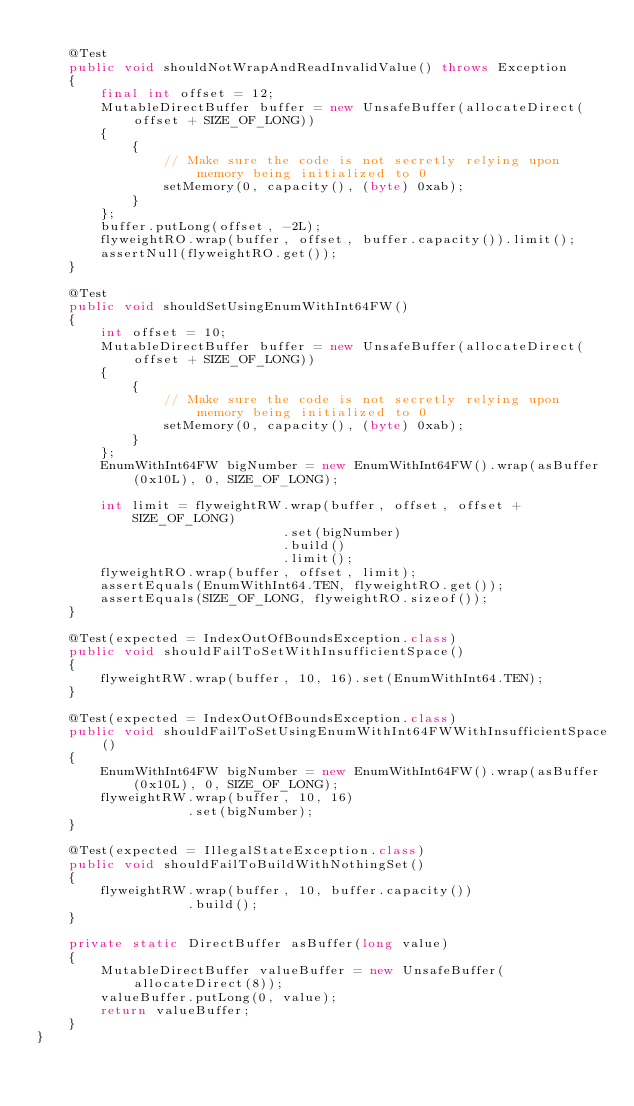Convert code to text. <code><loc_0><loc_0><loc_500><loc_500><_Java_>
    @Test
    public void shouldNotWrapAndReadInvalidValue() throws Exception
    {
        final int offset = 12;
        MutableDirectBuffer buffer = new UnsafeBuffer(allocateDirect(offset + SIZE_OF_LONG))
        {
            {
                // Make sure the code is not secretly relying upon memory being initialized to 0
                setMemory(0, capacity(), (byte) 0xab);
            }
        };
        buffer.putLong(offset, -2L);
        flyweightRO.wrap(buffer, offset, buffer.capacity()).limit();
        assertNull(flyweightRO.get());
    }

    @Test
    public void shouldSetUsingEnumWithInt64FW()
    {
        int offset = 10;
        MutableDirectBuffer buffer = new UnsafeBuffer(allocateDirect(offset + SIZE_OF_LONG))
        {
            {
                // Make sure the code is not secretly relying upon memory being initialized to 0
                setMemory(0, capacity(), (byte) 0xab);
            }
        };
        EnumWithInt64FW bigNumber = new EnumWithInt64FW().wrap(asBuffer(0x10L), 0, SIZE_OF_LONG);

        int limit = flyweightRW.wrap(buffer, offset, offset + SIZE_OF_LONG)
                               .set(bigNumber)
                               .build()
                               .limit();
        flyweightRO.wrap(buffer, offset, limit);
        assertEquals(EnumWithInt64.TEN, flyweightRO.get());
        assertEquals(SIZE_OF_LONG, flyweightRO.sizeof());
    }

    @Test(expected = IndexOutOfBoundsException.class)
    public void shouldFailToSetWithInsufficientSpace()
    {
        flyweightRW.wrap(buffer, 10, 16).set(EnumWithInt64.TEN);
    }

    @Test(expected = IndexOutOfBoundsException.class)
    public void shouldFailToSetUsingEnumWithInt64FWWithInsufficientSpace()
    {
        EnumWithInt64FW bigNumber = new EnumWithInt64FW().wrap(asBuffer(0x10L), 0, SIZE_OF_LONG);
        flyweightRW.wrap(buffer, 10, 16)
                   .set(bigNumber);
    }

    @Test(expected = IllegalStateException.class)
    public void shouldFailToBuildWithNothingSet()
    {
        flyweightRW.wrap(buffer, 10, buffer.capacity())
                   .build();
    }

    private static DirectBuffer asBuffer(long value)
    {
        MutableDirectBuffer valueBuffer = new UnsafeBuffer(allocateDirect(8));
        valueBuffer.putLong(0, value);
        return valueBuffer;
    }
}
</code> 